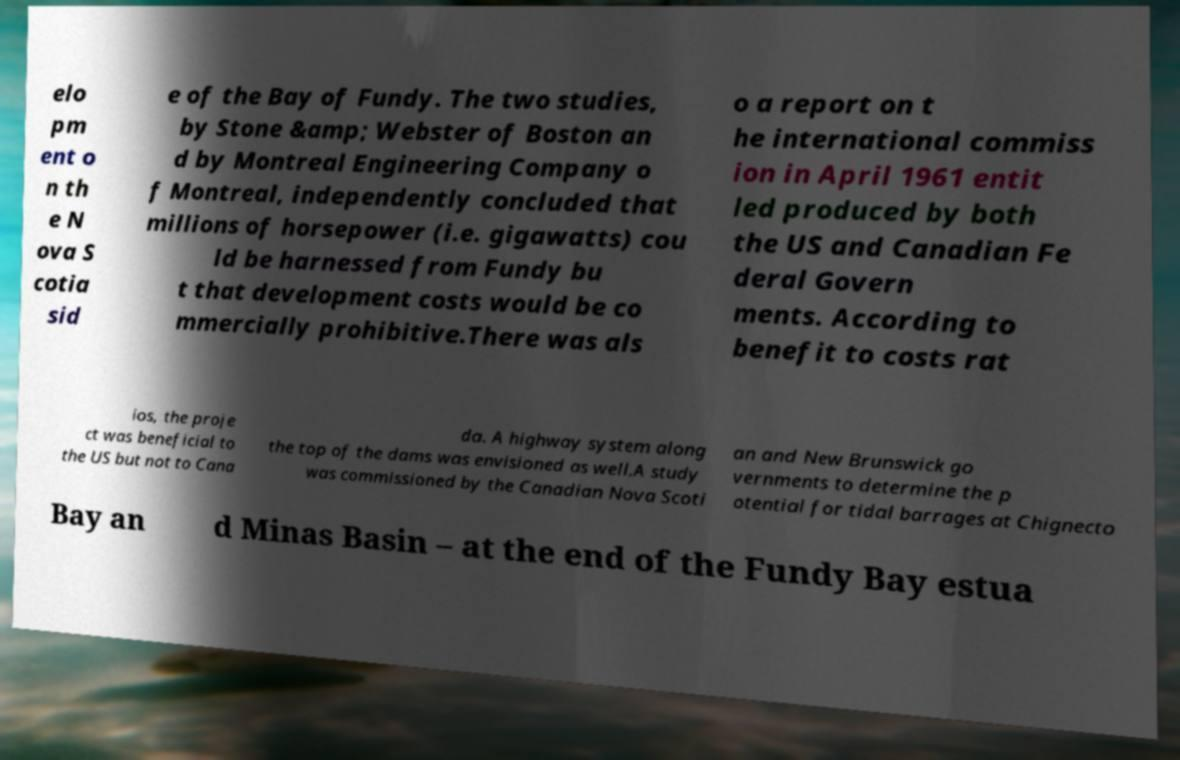Could you assist in decoding the text presented in this image and type it out clearly? elo pm ent o n th e N ova S cotia sid e of the Bay of Fundy. The two studies, by Stone &amp; Webster of Boston an d by Montreal Engineering Company o f Montreal, independently concluded that millions of horsepower (i.e. gigawatts) cou ld be harnessed from Fundy bu t that development costs would be co mmercially prohibitive.There was als o a report on t he international commiss ion in April 1961 entit led produced by both the US and Canadian Fe deral Govern ments. According to benefit to costs rat ios, the proje ct was beneficial to the US but not to Cana da. A highway system along the top of the dams was envisioned as well.A study was commissioned by the Canadian Nova Scoti an and New Brunswick go vernments to determine the p otential for tidal barrages at Chignecto Bay an d Minas Basin – at the end of the Fundy Bay estua 